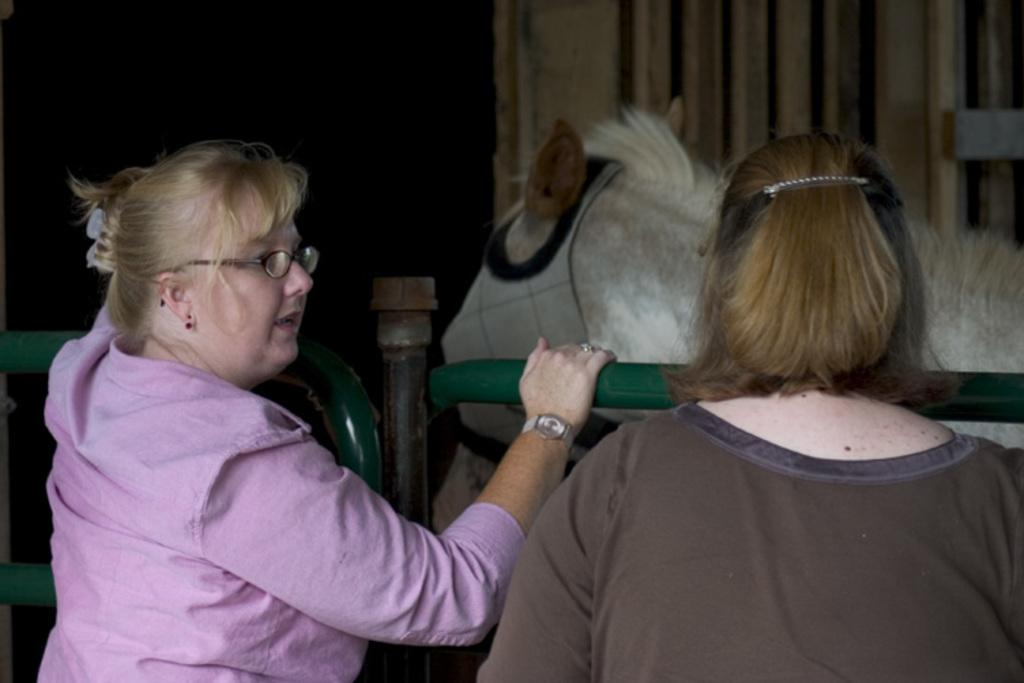How many people are present in the image? There are two people standing in the image. What are the people doing in the image? The people are standing at a railing. What can be seen behind the railing? There is a horse behind the railing. What is the background of the image? There is a wall in the image. What book is the servant reading in the image? There is no servant or book present in the image. How does the dock look like in the image? There is no dock present in the image. 